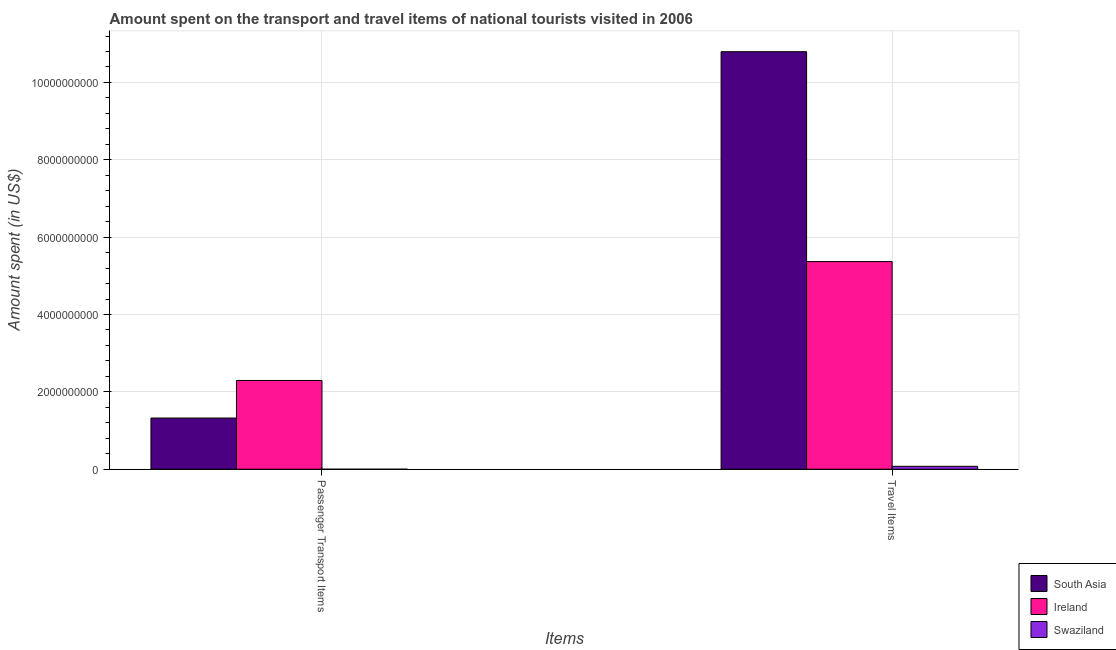How many different coloured bars are there?
Provide a succinct answer. 3. Are the number of bars on each tick of the X-axis equal?
Provide a succinct answer. Yes. How many bars are there on the 2nd tick from the left?
Your answer should be compact. 3. What is the label of the 2nd group of bars from the left?
Your response must be concise. Travel Items. What is the amount spent in travel items in Swaziland?
Offer a terse response. 7.50e+07. Across all countries, what is the maximum amount spent on passenger transport items?
Offer a terse response. 2.30e+09. Across all countries, what is the minimum amount spent on passenger transport items?
Offer a very short reply. 1.00e+05. In which country was the amount spent on passenger transport items maximum?
Your response must be concise. Ireland. In which country was the amount spent on passenger transport items minimum?
Provide a short and direct response. Swaziland. What is the total amount spent on passenger transport items in the graph?
Your answer should be compact. 3.62e+09. What is the difference between the amount spent on passenger transport items in Ireland and that in Swaziland?
Your answer should be compact. 2.29e+09. What is the difference between the amount spent in travel items in South Asia and the amount spent on passenger transport items in Ireland?
Offer a very short reply. 8.50e+09. What is the average amount spent in travel items per country?
Your answer should be compact. 5.41e+09. What is the difference between the amount spent on passenger transport items and amount spent in travel items in South Asia?
Provide a succinct answer. -9.47e+09. What is the ratio of the amount spent in travel items in Swaziland to that in Ireland?
Provide a succinct answer. 0.01. Is the amount spent in travel items in Swaziland less than that in South Asia?
Offer a terse response. Yes. What does the 2nd bar from the left in Passenger Transport Items represents?
Provide a short and direct response. Ireland. What does the 1st bar from the right in Passenger Transport Items represents?
Provide a succinct answer. Swaziland. How many bars are there?
Your answer should be compact. 6. Are all the bars in the graph horizontal?
Your answer should be compact. No. What is the difference between two consecutive major ticks on the Y-axis?
Keep it short and to the point. 2.00e+09. Does the graph contain any zero values?
Your response must be concise. No. Does the graph contain grids?
Your response must be concise. Yes. Where does the legend appear in the graph?
Provide a succinct answer. Bottom right. What is the title of the graph?
Offer a very short reply. Amount spent on the transport and travel items of national tourists visited in 2006. What is the label or title of the X-axis?
Ensure brevity in your answer.  Items. What is the label or title of the Y-axis?
Keep it short and to the point. Amount spent (in US$). What is the Amount spent (in US$) in South Asia in Passenger Transport Items?
Your answer should be very brief. 1.32e+09. What is the Amount spent (in US$) of Ireland in Passenger Transport Items?
Your answer should be very brief. 2.30e+09. What is the Amount spent (in US$) in Swaziland in Passenger Transport Items?
Make the answer very short. 1.00e+05. What is the Amount spent (in US$) of South Asia in Travel Items?
Your answer should be compact. 1.08e+1. What is the Amount spent (in US$) in Ireland in Travel Items?
Ensure brevity in your answer.  5.37e+09. What is the Amount spent (in US$) in Swaziland in Travel Items?
Make the answer very short. 7.50e+07. Across all Items, what is the maximum Amount spent (in US$) of South Asia?
Provide a short and direct response. 1.08e+1. Across all Items, what is the maximum Amount spent (in US$) of Ireland?
Keep it short and to the point. 5.37e+09. Across all Items, what is the maximum Amount spent (in US$) in Swaziland?
Your answer should be compact. 7.50e+07. Across all Items, what is the minimum Amount spent (in US$) in South Asia?
Make the answer very short. 1.32e+09. Across all Items, what is the minimum Amount spent (in US$) of Ireland?
Your response must be concise. 2.30e+09. Across all Items, what is the minimum Amount spent (in US$) in Swaziland?
Your answer should be compact. 1.00e+05. What is the total Amount spent (in US$) in South Asia in the graph?
Make the answer very short. 1.21e+1. What is the total Amount spent (in US$) of Ireland in the graph?
Make the answer very short. 7.66e+09. What is the total Amount spent (in US$) of Swaziland in the graph?
Give a very brief answer. 7.51e+07. What is the difference between the Amount spent (in US$) of South Asia in Passenger Transport Items and that in Travel Items?
Offer a very short reply. -9.47e+09. What is the difference between the Amount spent (in US$) in Ireland in Passenger Transport Items and that in Travel Items?
Your response must be concise. -3.07e+09. What is the difference between the Amount spent (in US$) of Swaziland in Passenger Transport Items and that in Travel Items?
Offer a very short reply. -7.49e+07. What is the difference between the Amount spent (in US$) in South Asia in Passenger Transport Items and the Amount spent (in US$) in Ireland in Travel Items?
Your answer should be very brief. -4.05e+09. What is the difference between the Amount spent (in US$) of South Asia in Passenger Transport Items and the Amount spent (in US$) of Swaziland in Travel Items?
Your answer should be very brief. 1.25e+09. What is the difference between the Amount spent (in US$) of Ireland in Passenger Transport Items and the Amount spent (in US$) of Swaziland in Travel Items?
Your response must be concise. 2.22e+09. What is the average Amount spent (in US$) of South Asia per Items?
Ensure brevity in your answer.  6.06e+09. What is the average Amount spent (in US$) in Ireland per Items?
Your answer should be compact. 3.83e+09. What is the average Amount spent (in US$) in Swaziland per Items?
Offer a very short reply. 3.76e+07. What is the difference between the Amount spent (in US$) of South Asia and Amount spent (in US$) of Ireland in Passenger Transport Items?
Your answer should be very brief. -9.72e+08. What is the difference between the Amount spent (in US$) in South Asia and Amount spent (in US$) in Swaziland in Passenger Transport Items?
Your answer should be compact. 1.32e+09. What is the difference between the Amount spent (in US$) of Ireland and Amount spent (in US$) of Swaziland in Passenger Transport Items?
Provide a succinct answer. 2.29e+09. What is the difference between the Amount spent (in US$) of South Asia and Amount spent (in US$) of Ireland in Travel Items?
Your answer should be compact. 5.43e+09. What is the difference between the Amount spent (in US$) of South Asia and Amount spent (in US$) of Swaziland in Travel Items?
Offer a terse response. 1.07e+1. What is the difference between the Amount spent (in US$) in Ireland and Amount spent (in US$) in Swaziland in Travel Items?
Your answer should be very brief. 5.29e+09. What is the ratio of the Amount spent (in US$) in South Asia in Passenger Transport Items to that in Travel Items?
Your response must be concise. 0.12. What is the ratio of the Amount spent (in US$) of Ireland in Passenger Transport Items to that in Travel Items?
Offer a very short reply. 0.43. What is the ratio of the Amount spent (in US$) of Swaziland in Passenger Transport Items to that in Travel Items?
Keep it short and to the point. 0. What is the difference between the highest and the second highest Amount spent (in US$) of South Asia?
Keep it short and to the point. 9.47e+09. What is the difference between the highest and the second highest Amount spent (in US$) in Ireland?
Your answer should be very brief. 3.07e+09. What is the difference between the highest and the second highest Amount spent (in US$) in Swaziland?
Provide a short and direct response. 7.49e+07. What is the difference between the highest and the lowest Amount spent (in US$) in South Asia?
Give a very brief answer. 9.47e+09. What is the difference between the highest and the lowest Amount spent (in US$) in Ireland?
Your response must be concise. 3.07e+09. What is the difference between the highest and the lowest Amount spent (in US$) of Swaziland?
Offer a terse response. 7.49e+07. 